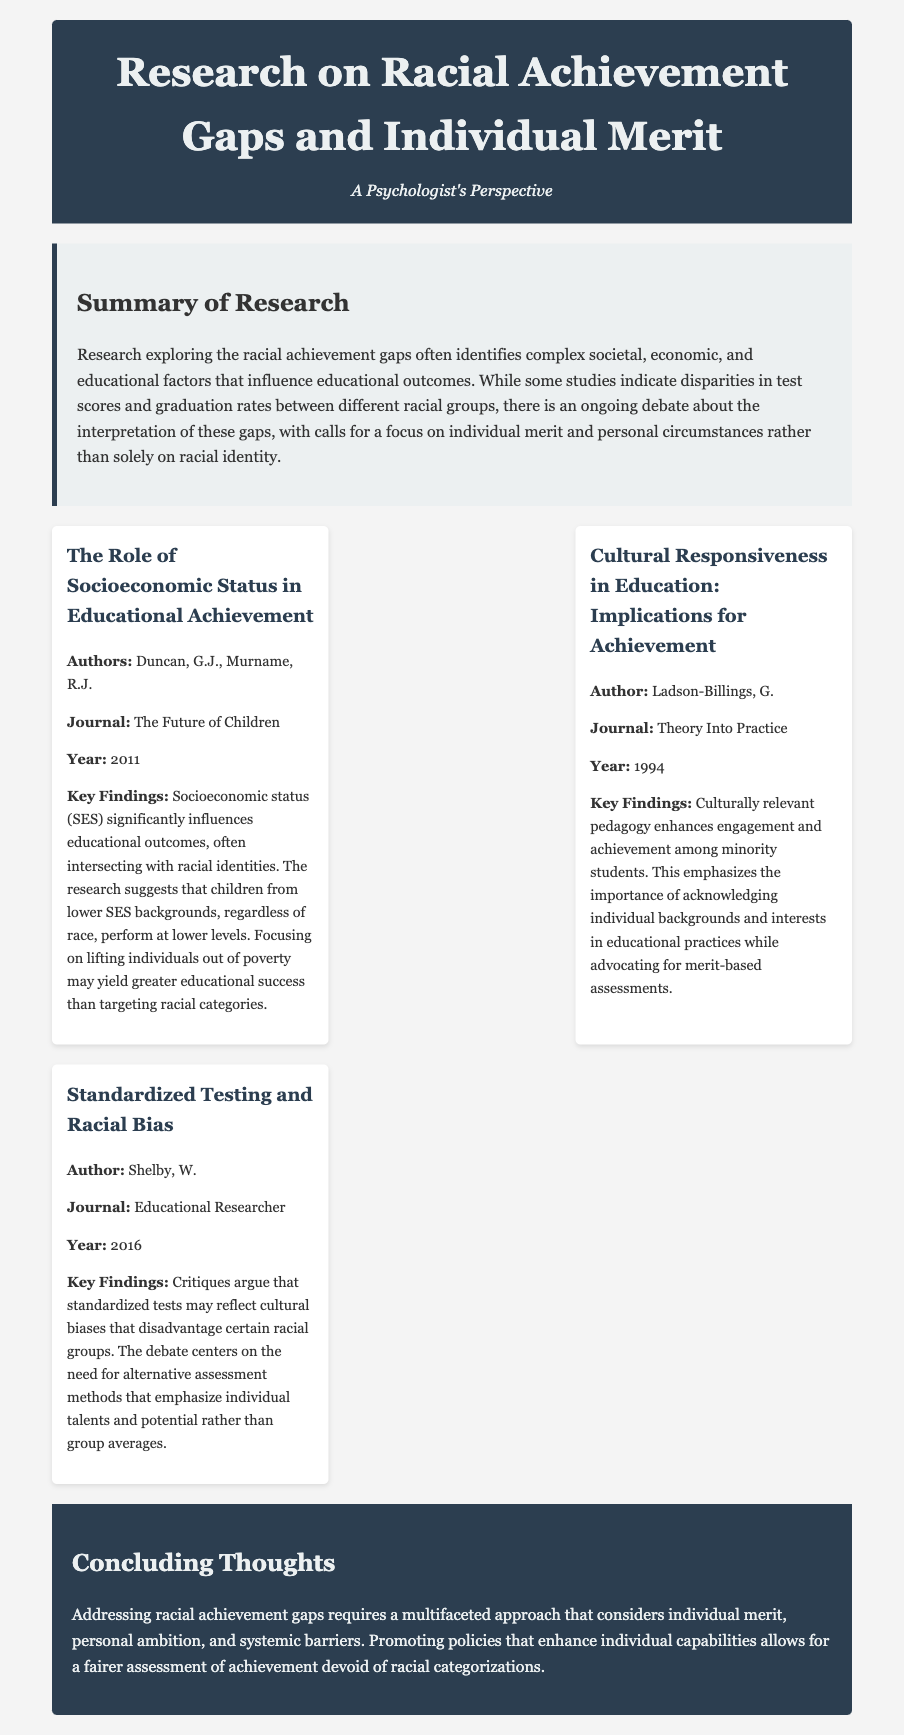what is the title of the document? The title of the document is provided in the header section.
Answer: Research on Racial Achievement Gaps and Individual Merit who are the authors of the first research finding? The authors for the first research finding are listed under the key findings section.
Answer: Duncan, G.J., Murname, R.J what year was the research on cultural responsiveness published? The year of publication is mentioned alongside the research item title.
Answer: 1994 what is the main focus of the concluding thoughts? The concluding thoughts summarize the findings and provide a perspective on addressing the issues discussed.
Answer: Individual merit what journal published the research on standardized testing? The journal is specified in the research item section for standardized testing.
Answer: Educational Researcher how many key findings are mentioned in the research items? The total number of key findings is indicated by the number of research items presented.
Answer: Three what is the main argument of the second research finding? The main argument is provided in the key findings of the second research item.
Answer: Culturally relevant pedagogy enhances engagement what does SES stand for in the context of the first research finding? SES is a term used in social research, explained in the context of the research findings.
Answer: Socioeconomic Status who is the author of the research on racial bias? The author is listed under the research item for racial bias.
Answer: Shelby, W 